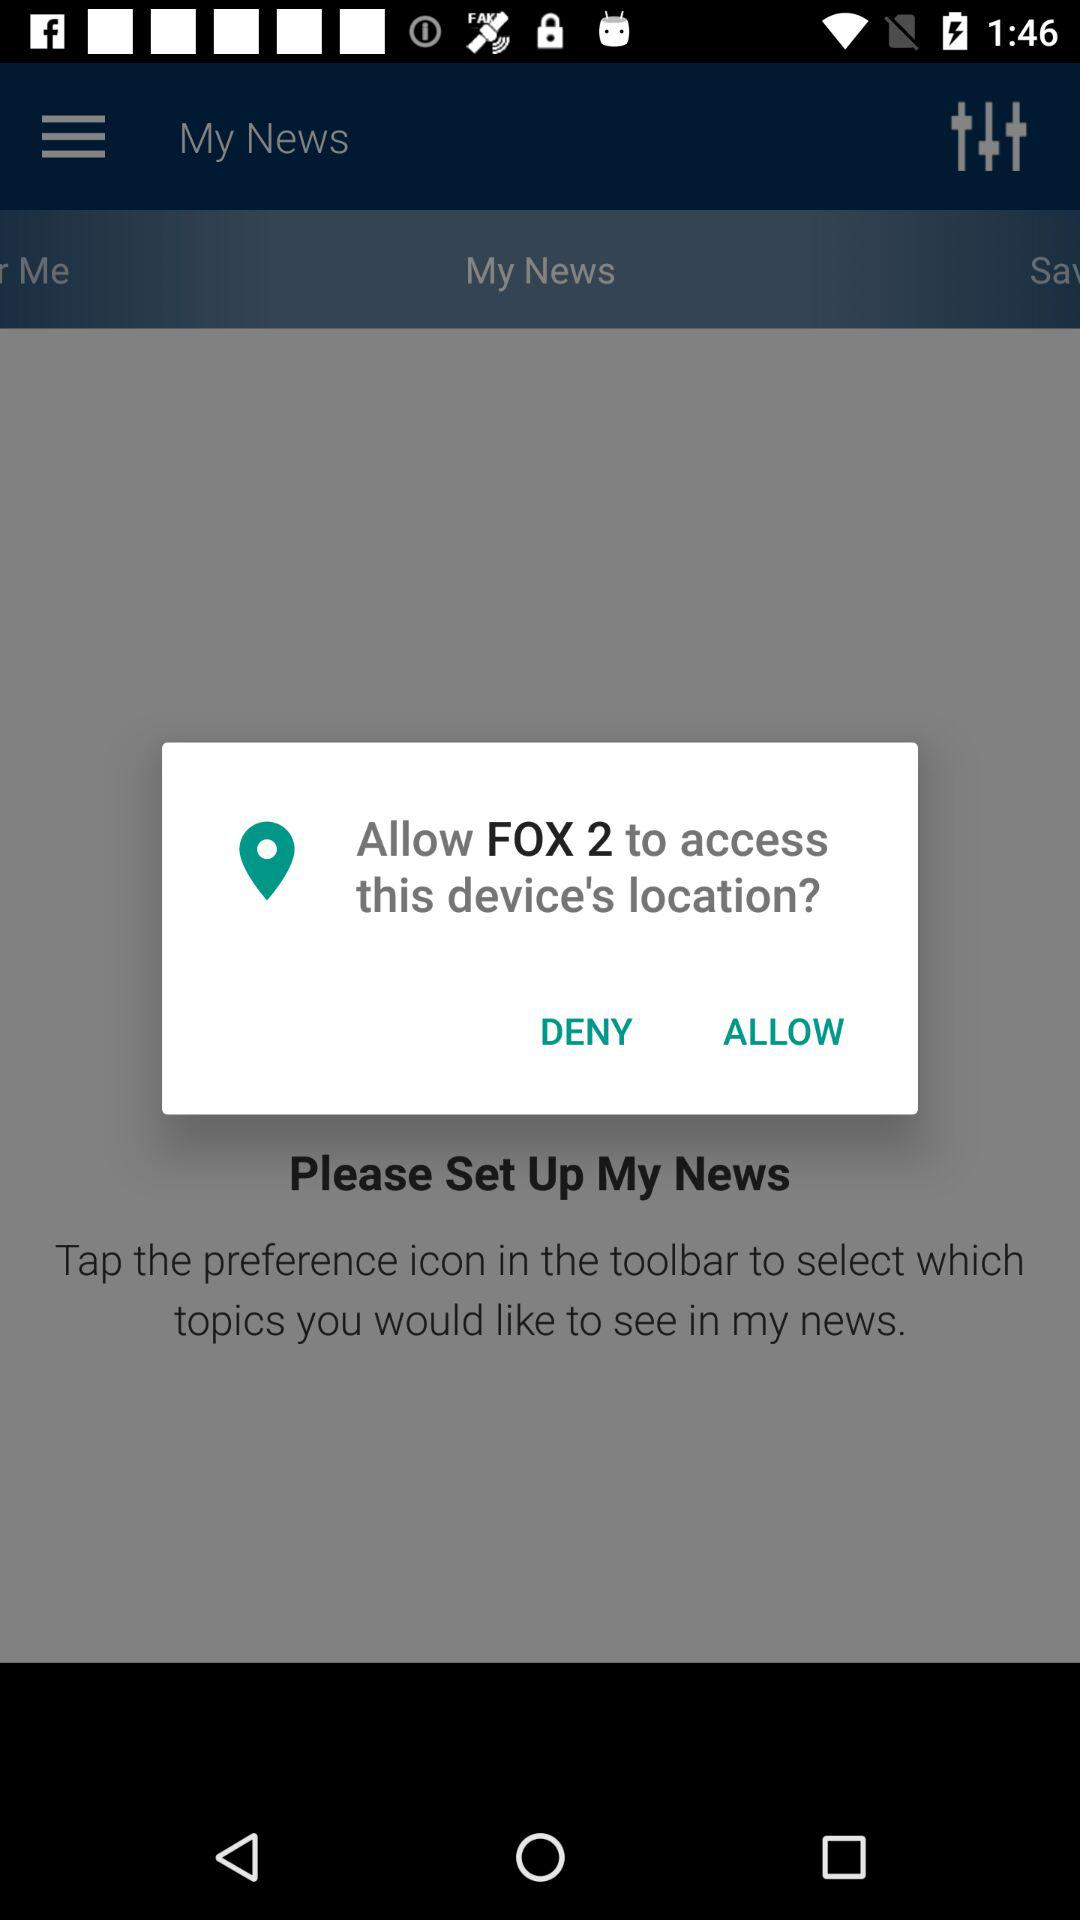What application has asked for permission? The application "FOX 2" has asked for permission. 